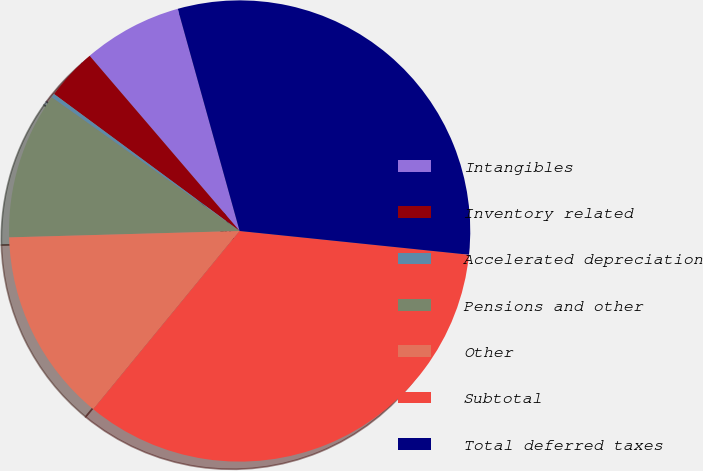Convert chart. <chart><loc_0><loc_0><loc_500><loc_500><pie_chart><fcel>Intangibles<fcel>Inventory related<fcel>Accelerated depreciation<fcel>Pensions and other<fcel>Other<fcel>Subtotal<fcel>Total deferred taxes<nl><fcel>6.95%<fcel>3.61%<fcel>0.28%<fcel>10.28%<fcel>13.62%<fcel>34.3%<fcel>30.96%<nl></chart> 